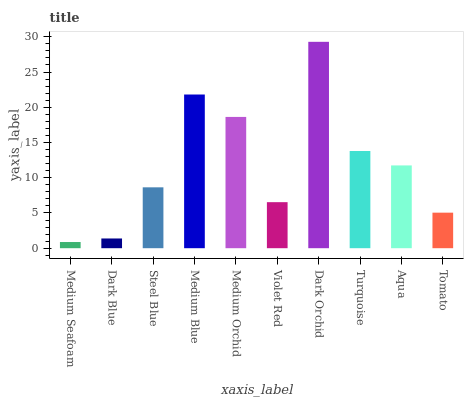Is Medium Seafoam the minimum?
Answer yes or no. Yes. Is Dark Orchid the maximum?
Answer yes or no. Yes. Is Dark Blue the minimum?
Answer yes or no. No. Is Dark Blue the maximum?
Answer yes or no. No. Is Dark Blue greater than Medium Seafoam?
Answer yes or no. Yes. Is Medium Seafoam less than Dark Blue?
Answer yes or no. Yes. Is Medium Seafoam greater than Dark Blue?
Answer yes or no. No. Is Dark Blue less than Medium Seafoam?
Answer yes or no. No. Is Aqua the high median?
Answer yes or no. Yes. Is Steel Blue the low median?
Answer yes or no. Yes. Is Medium Seafoam the high median?
Answer yes or no. No. Is Violet Red the low median?
Answer yes or no. No. 